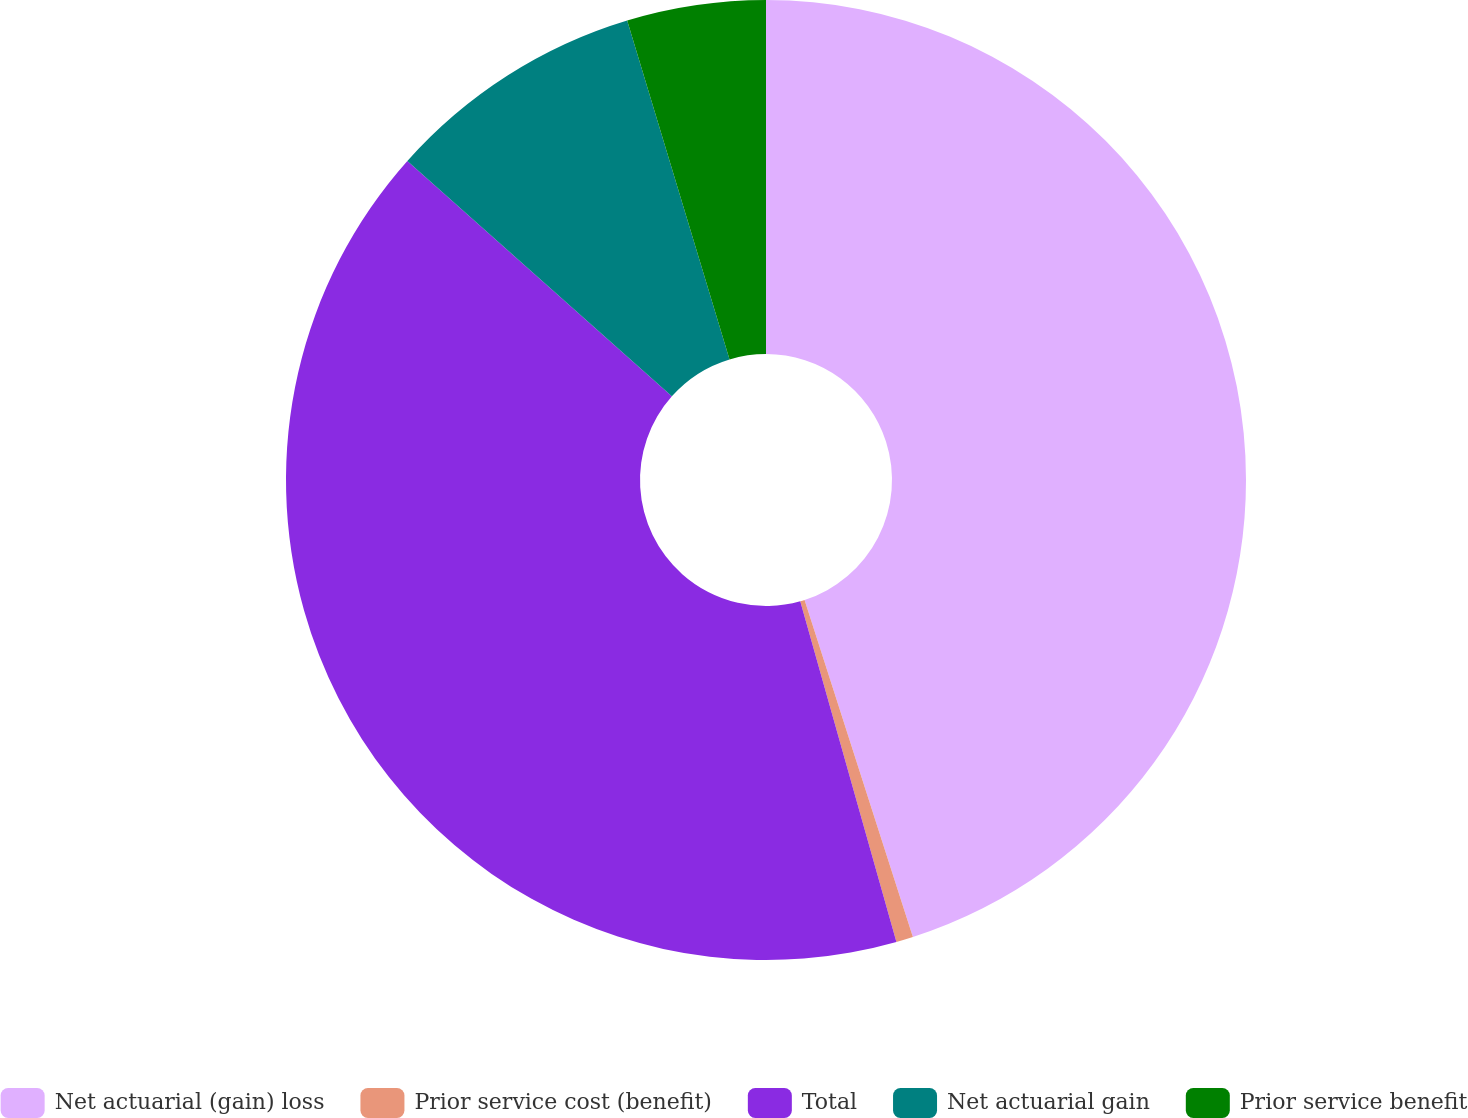Convert chart to OTSL. <chart><loc_0><loc_0><loc_500><loc_500><pie_chart><fcel>Net actuarial (gain) loss<fcel>Prior service cost (benefit)<fcel>Total<fcel>Net actuarial gain<fcel>Prior service benefit<nl><fcel>45.05%<fcel>0.57%<fcel>40.95%<fcel>8.76%<fcel>4.67%<nl></chart> 